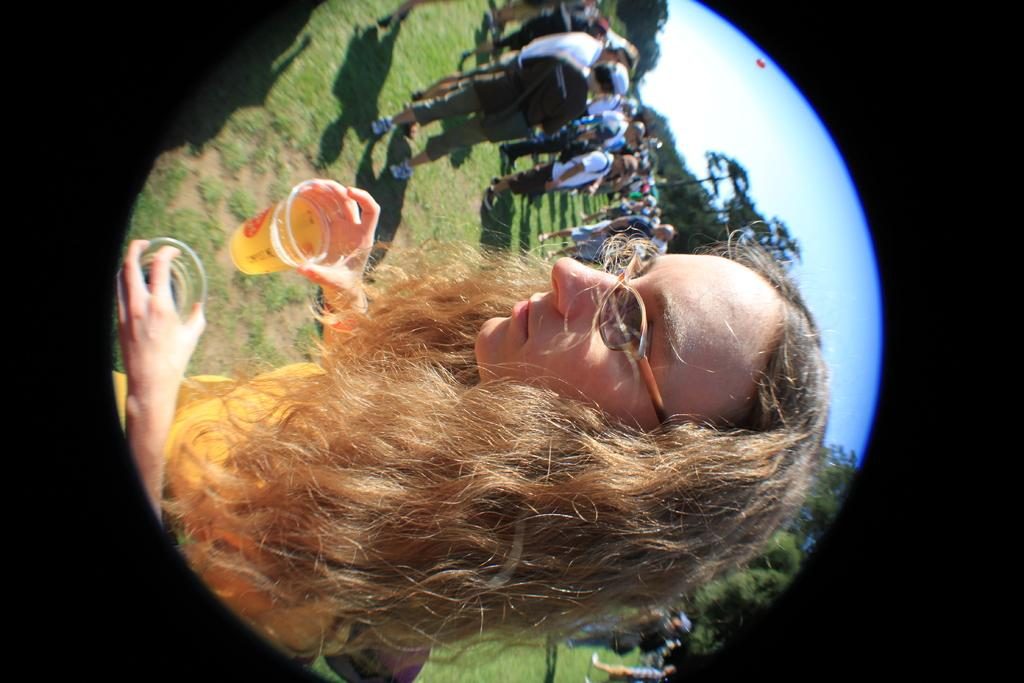What is the main subject of the image? There is a group of people in the image. Can you describe the woman in the image? There is a woman in the middle of the image, and she is holding glasses. What can be seen in the background of the image? There are trees in the background of the image. What type of cloth is draped over the wealth in the image? There is no mention of wealth or cloth in the image; it features a group of people with a woman holding glasses and trees in the background. 